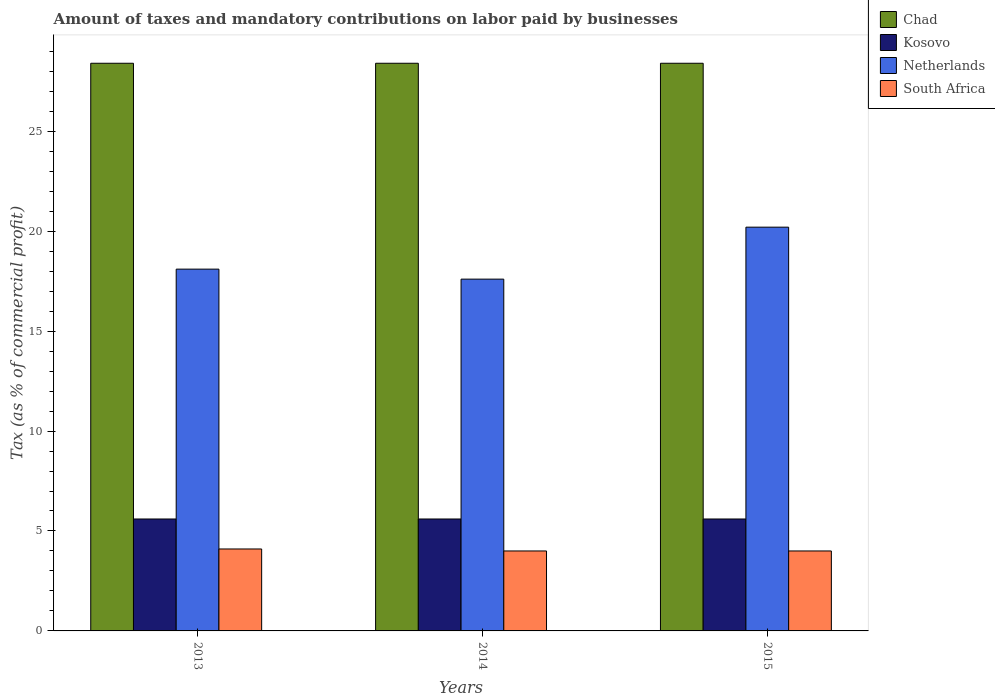Are the number of bars on each tick of the X-axis equal?
Keep it short and to the point. Yes. How many bars are there on the 3rd tick from the left?
Give a very brief answer. 4. How many bars are there on the 1st tick from the right?
Make the answer very short. 4. What is the label of the 2nd group of bars from the left?
Offer a terse response. 2014. What is the percentage of taxes paid by businesses in Chad in 2015?
Keep it short and to the point. 28.4. Across all years, what is the maximum percentage of taxes paid by businesses in Chad?
Your answer should be very brief. 28.4. Across all years, what is the minimum percentage of taxes paid by businesses in Netherlands?
Your answer should be compact. 17.6. In which year was the percentage of taxes paid by businesses in South Africa maximum?
Your response must be concise. 2013. What is the total percentage of taxes paid by businesses in Chad in the graph?
Give a very brief answer. 85.2. What is the difference between the percentage of taxes paid by businesses in Chad in 2013 and that in 2014?
Your answer should be very brief. 0. What is the difference between the percentage of taxes paid by businesses in Chad in 2015 and the percentage of taxes paid by businesses in South Africa in 2013?
Your answer should be compact. 24.3. What is the average percentage of taxes paid by businesses in Kosovo per year?
Your answer should be compact. 5.6. In the year 2015, what is the difference between the percentage of taxes paid by businesses in Kosovo and percentage of taxes paid by businesses in South Africa?
Make the answer very short. 1.6. What is the difference between the highest and the lowest percentage of taxes paid by businesses in South Africa?
Provide a short and direct response. 0.1. What does the 3rd bar from the left in 2015 represents?
Give a very brief answer. Netherlands. Are all the bars in the graph horizontal?
Ensure brevity in your answer.  No. How many years are there in the graph?
Provide a succinct answer. 3. What is the difference between two consecutive major ticks on the Y-axis?
Offer a terse response. 5. Are the values on the major ticks of Y-axis written in scientific E-notation?
Make the answer very short. No. Does the graph contain any zero values?
Offer a very short reply. No. Does the graph contain grids?
Offer a terse response. No. How many legend labels are there?
Your answer should be very brief. 4. How are the legend labels stacked?
Provide a short and direct response. Vertical. What is the title of the graph?
Ensure brevity in your answer.  Amount of taxes and mandatory contributions on labor paid by businesses. What is the label or title of the X-axis?
Ensure brevity in your answer.  Years. What is the label or title of the Y-axis?
Offer a very short reply. Tax (as % of commercial profit). What is the Tax (as % of commercial profit) of Chad in 2013?
Keep it short and to the point. 28.4. What is the Tax (as % of commercial profit) of Kosovo in 2013?
Your answer should be compact. 5.6. What is the Tax (as % of commercial profit) of Chad in 2014?
Your response must be concise. 28.4. What is the Tax (as % of commercial profit) in Kosovo in 2014?
Provide a succinct answer. 5.6. What is the Tax (as % of commercial profit) in South Africa in 2014?
Make the answer very short. 4. What is the Tax (as % of commercial profit) in Chad in 2015?
Keep it short and to the point. 28.4. What is the Tax (as % of commercial profit) of Netherlands in 2015?
Make the answer very short. 20.2. Across all years, what is the maximum Tax (as % of commercial profit) of Chad?
Your answer should be very brief. 28.4. Across all years, what is the maximum Tax (as % of commercial profit) in Netherlands?
Your answer should be very brief. 20.2. Across all years, what is the maximum Tax (as % of commercial profit) of South Africa?
Your response must be concise. 4.1. Across all years, what is the minimum Tax (as % of commercial profit) of Chad?
Make the answer very short. 28.4. Across all years, what is the minimum Tax (as % of commercial profit) in Kosovo?
Keep it short and to the point. 5.6. What is the total Tax (as % of commercial profit) of Chad in the graph?
Ensure brevity in your answer.  85.2. What is the total Tax (as % of commercial profit) of Kosovo in the graph?
Offer a very short reply. 16.8. What is the total Tax (as % of commercial profit) in Netherlands in the graph?
Offer a very short reply. 55.9. What is the total Tax (as % of commercial profit) in South Africa in the graph?
Make the answer very short. 12.1. What is the difference between the Tax (as % of commercial profit) in Kosovo in 2013 and that in 2014?
Your answer should be compact. 0. What is the difference between the Tax (as % of commercial profit) of Netherlands in 2013 and that in 2014?
Keep it short and to the point. 0.5. What is the difference between the Tax (as % of commercial profit) of Chad in 2013 and that in 2015?
Offer a terse response. 0. What is the difference between the Tax (as % of commercial profit) of Kosovo in 2013 and that in 2015?
Offer a very short reply. 0. What is the difference between the Tax (as % of commercial profit) in South Africa in 2013 and that in 2015?
Make the answer very short. 0.1. What is the difference between the Tax (as % of commercial profit) of Netherlands in 2014 and that in 2015?
Ensure brevity in your answer.  -2.6. What is the difference between the Tax (as % of commercial profit) in Chad in 2013 and the Tax (as % of commercial profit) in Kosovo in 2014?
Your answer should be very brief. 22.8. What is the difference between the Tax (as % of commercial profit) in Chad in 2013 and the Tax (as % of commercial profit) in South Africa in 2014?
Ensure brevity in your answer.  24.4. What is the difference between the Tax (as % of commercial profit) in Kosovo in 2013 and the Tax (as % of commercial profit) in Netherlands in 2014?
Keep it short and to the point. -12. What is the difference between the Tax (as % of commercial profit) of Netherlands in 2013 and the Tax (as % of commercial profit) of South Africa in 2014?
Offer a very short reply. 14.1. What is the difference between the Tax (as % of commercial profit) of Chad in 2013 and the Tax (as % of commercial profit) of Kosovo in 2015?
Offer a terse response. 22.8. What is the difference between the Tax (as % of commercial profit) of Chad in 2013 and the Tax (as % of commercial profit) of Netherlands in 2015?
Provide a short and direct response. 8.2. What is the difference between the Tax (as % of commercial profit) in Chad in 2013 and the Tax (as % of commercial profit) in South Africa in 2015?
Keep it short and to the point. 24.4. What is the difference between the Tax (as % of commercial profit) of Kosovo in 2013 and the Tax (as % of commercial profit) of Netherlands in 2015?
Ensure brevity in your answer.  -14.6. What is the difference between the Tax (as % of commercial profit) of Chad in 2014 and the Tax (as % of commercial profit) of Kosovo in 2015?
Keep it short and to the point. 22.8. What is the difference between the Tax (as % of commercial profit) in Chad in 2014 and the Tax (as % of commercial profit) in South Africa in 2015?
Give a very brief answer. 24.4. What is the difference between the Tax (as % of commercial profit) in Kosovo in 2014 and the Tax (as % of commercial profit) in Netherlands in 2015?
Offer a terse response. -14.6. What is the difference between the Tax (as % of commercial profit) in Kosovo in 2014 and the Tax (as % of commercial profit) in South Africa in 2015?
Provide a succinct answer. 1.6. What is the difference between the Tax (as % of commercial profit) in Netherlands in 2014 and the Tax (as % of commercial profit) in South Africa in 2015?
Provide a short and direct response. 13.6. What is the average Tax (as % of commercial profit) of Chad per year?
Ensure brevity in your answer.  28.4. What is the average Tax (as % of commercial profit) of Kosovo per year?
Your response must be concise. 5.6. What is the average Tax (as % of commercial profit) of Netherlands per year?
Keep it short and to the point. 18.63. What is the average Tax (as % of commercial profit) in South Africa per year?
Provide a short and direct response. 4.03. In the year 2013, what is the difference between the Tax (as % of commercial profit) in Chad and Tax (as % of commercial profit) in Kosovo?
Ensure brevity in your answer.  22.8. In the year 2013, what is the difference between the Tax (as % of commercial profit) in Chad and Tax (as % of commercial profit) in South Africa?
Offer a very short reply. 24.3. In the year 2013, what is the difference between the Tax (as % of commercial profit) of Kosovo and Tax (as % of commercial profit) of Netherlands?
Offer a very short reply. -12.5. In the year 2014, what is the difference between the Tax (as % of commercial profit) in Chad and Tax (as % of commercial profit) in Kosovo?
Give a very brief answer. 22.8. In the year 2014, what is the difference between the Tax (as % of commercial profit) of Chad and Tax (as % of commercial profit) of South Africa?
Offer a very short reply. 24.4. In the year 2014, what is the difference between the Tax (as % of commercial profit) in Kosovo and Tax (as % of commercial profit) in Netherlands?
Offer a very short reply. -12. In the year 2014, what is the difference between the Tax (as % of commercial profit) in Kosovo and Tax (as % of commercial profit) in South Africa?
Your response must be concise. 1.6. In the year 2015, what is the difference between the Tax (as % of commercial profit) of Chad and Tax (as % of commercial profit) of Kosovo?
Give a very brief answer. 22.8. In the year 2015, what is the difference between the Tax (as % of commercial profit) of Chad and Tax (as % of commercial profit) of South Africa?
Your answer should be compact. 24.4. In the year 2015, what is the difference between the Tax (as % of commercial profit) of Kosovo and Tax (as % of commercial profit) of Netherlands?
Your answer should be very brief. -14.6. In the year 2015, what is the difference between the Tax (as % of commercial profit) of Netherlands and Tax (as % of commercial profit) of South Africa?
Keep it short and to the point. 16.2. What is the ratio of the Tax (as % of commercial profit) of Kosovo in 2013 to that in 2014?
Offer a terse response. 1. What is the ratio of the Tax (as % of commercial profit) of Netherlands in 2013 to that in 2014?
Provide a short and direct response. 1.03. What is the ratio of the Tax (as % of commercial profit) in South Africa in 2013 to that in 2014?
Offer a very short reply. 1.02. What is the ratio of the Tax (as % of commercial profit) of Kosovo in 2013 to that in 2015?
Give a very brief answer. 1. What is the ratio of the Tax (as % of commercial profit) of Netherlands in 2013 to that in 2015?
Your answer should be very brief. 0.9. What is the ratio of the Tax (as % of commercial profit) of South Africa in 2013 to that in 2015?
Your answer should be very brief. 1.02. What is the ratio of the Tax (as % of commercial profit) in Chad in 2014 to that in 2015?
Your answer should be very brief. 1. What is the ratio of the Tax (as % of commercial profit) in Kosovo in 2014 to that in 2015?
Offer a terse response. 1. What is the ratio of the Tax (as % of commercial profit) of Netherlands in 2014 to that in 2015?
Your response must be concise. 0.87. What is the ratio of the Tax (as % of commercial profit) in South Africa in 2014 to that in 2015?
Keep it short and to the point. 1. What is the difference between the highest and the second highest Tax (as % of commercial profit) in Chad?
Your answer should be very brief. 0. What is the difference between the highest and the second highest Tax (as % of commercial profit) of Kosovo?
Provide a short and direct response. 0. What is the difference between the highest and the second highest Tax (as % of commercial profit) in Netherlands?
Your answer should be compact. 2.1. What is the difference between the highest and the second highest Tax (as % of commercial profit) of South Africa?
Make the answer very short. 0.1. What is the difference between the highest and the lowest Tax (as % of commercial profit) in Chad?
Give a very brief answer. 0. What is the difference between the highest and the lowest Tax (as % of commercial profit) in Kosovo?
Keep it short and to the point. 0. What is the difference between the highest and the lowest Tax (as % of commercial profit) of Netherlands?
Give a very brief answer. 2.6. 